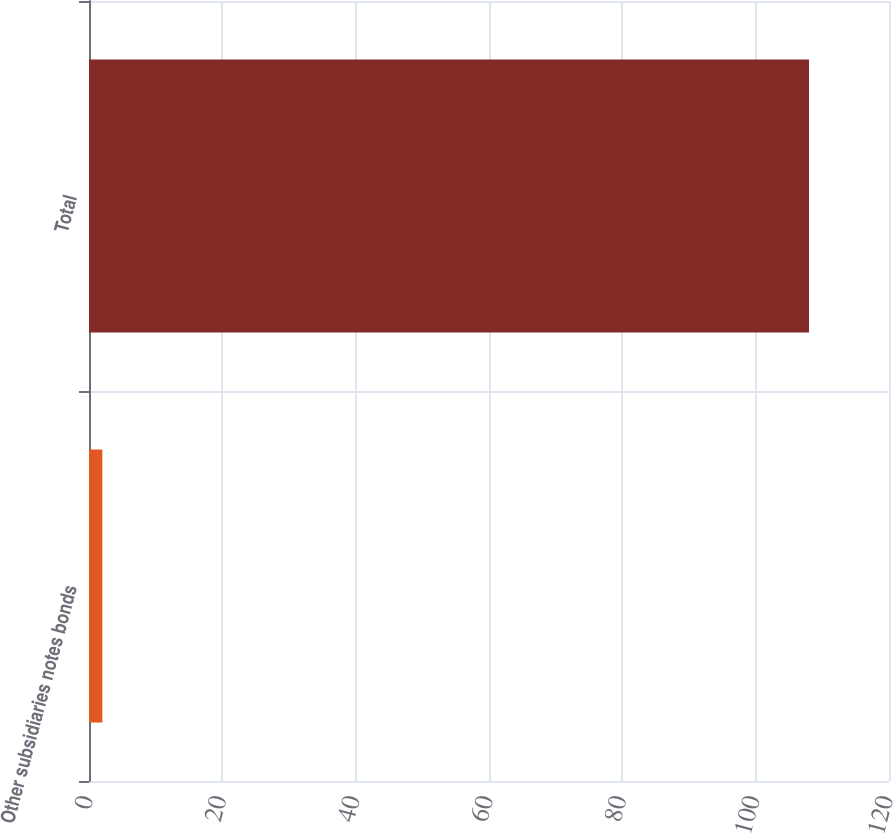Convert chart. <chart><loc_0><loc_0><loc_500><loc_500><bar_chart><fcel>Other subsidiaries notes bonds<fcel>Total<nl><fcel>2<fcel>108<nl></chart> 